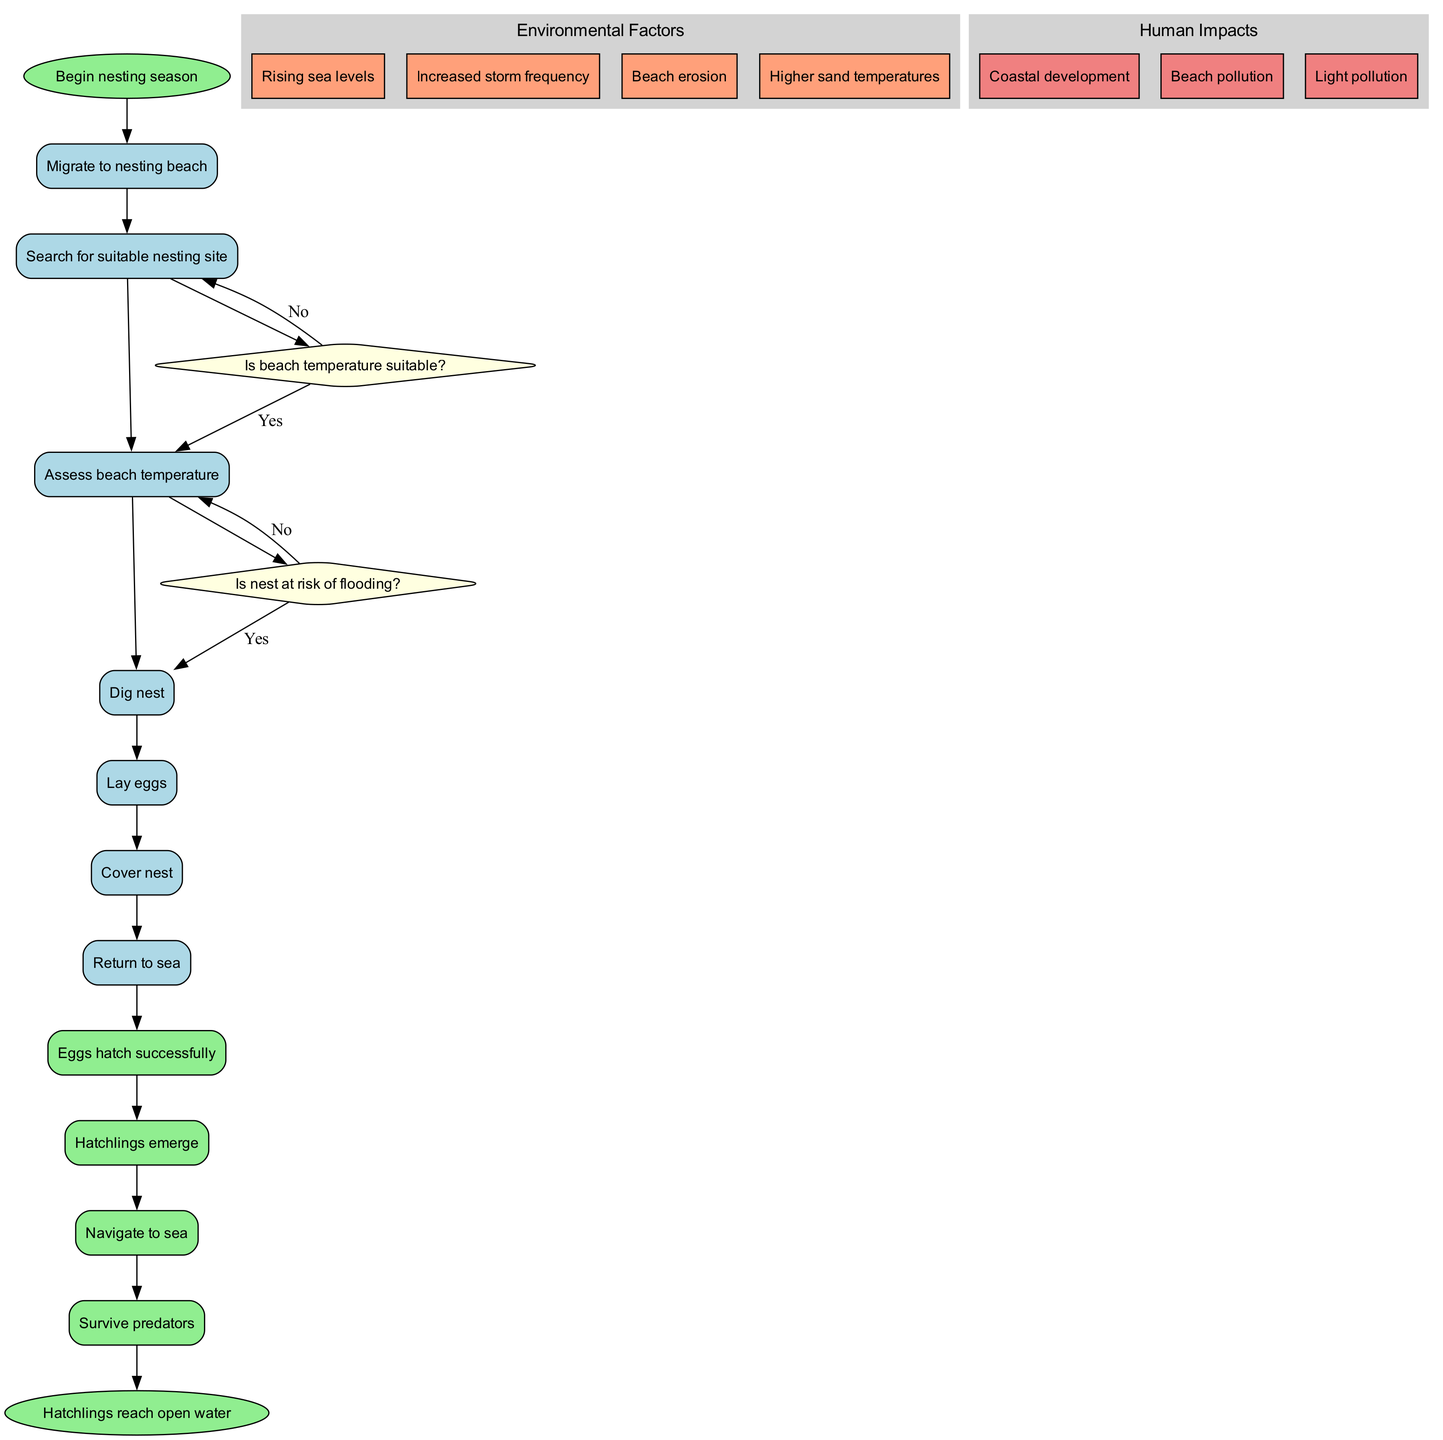What is the starting point of the activity diagram? The starting point of the activity diagram is the node labeled "Begin nesting season", which indicates the initiation of the nesting process for the sea turtles.
Answer: Begin nesting season How many decision points are present in the diagram? The diagram includes two decision points, which are indicated by the diamond shapes that represent questions about beach temperature and nesting risks.
Answer: 2 What action follows after assessing beach temperature if it's not suitable? If the beach temperature is not suitable, the next action is to "Search for alternative site" before proceeding to dig a nest.
Answer: Search for alternative site What are two environmental factors that impact sea turtle nesting? Two environmental factors listed in the diagram that impact nesting are "Rising sea levels" and "Higher sand temperatures".
Answer: Rising sea levels, Higher sand temperatures What happens if the nest is at risk of flooding? If the nest is at risk of flooding, the action taken is to "Relocate nest" to a safer location, ensuring better chances for hatchling survival.
Answer: Relocate nest Which activity occurs just before eggs hatch successfully? The activity that occurs just before the eggs hatch successfully is "Cover nest," which takes place after laying eggs.
Answer: Cover nest After hatchlings emerge, what is the next step they take? After emergence, the next step for the hatchlings is to "Navigate to sea," which is essential for their survival in the ocean.
Answer: Navigate to sea What is the final outcome noted in the diagram? The final outcome noted in the diagram is that "Hatchlings reach open water," which signifies their successful transition from the nest to the sea.
Answer: Hatchlings reach open water What is listed as a human impact on sea turtle nesting? One of the human impacts listed in the diagram is "Beach pollution," which can significantly harm nesting sites and hatchling survival.
Answer: Beach pollution 